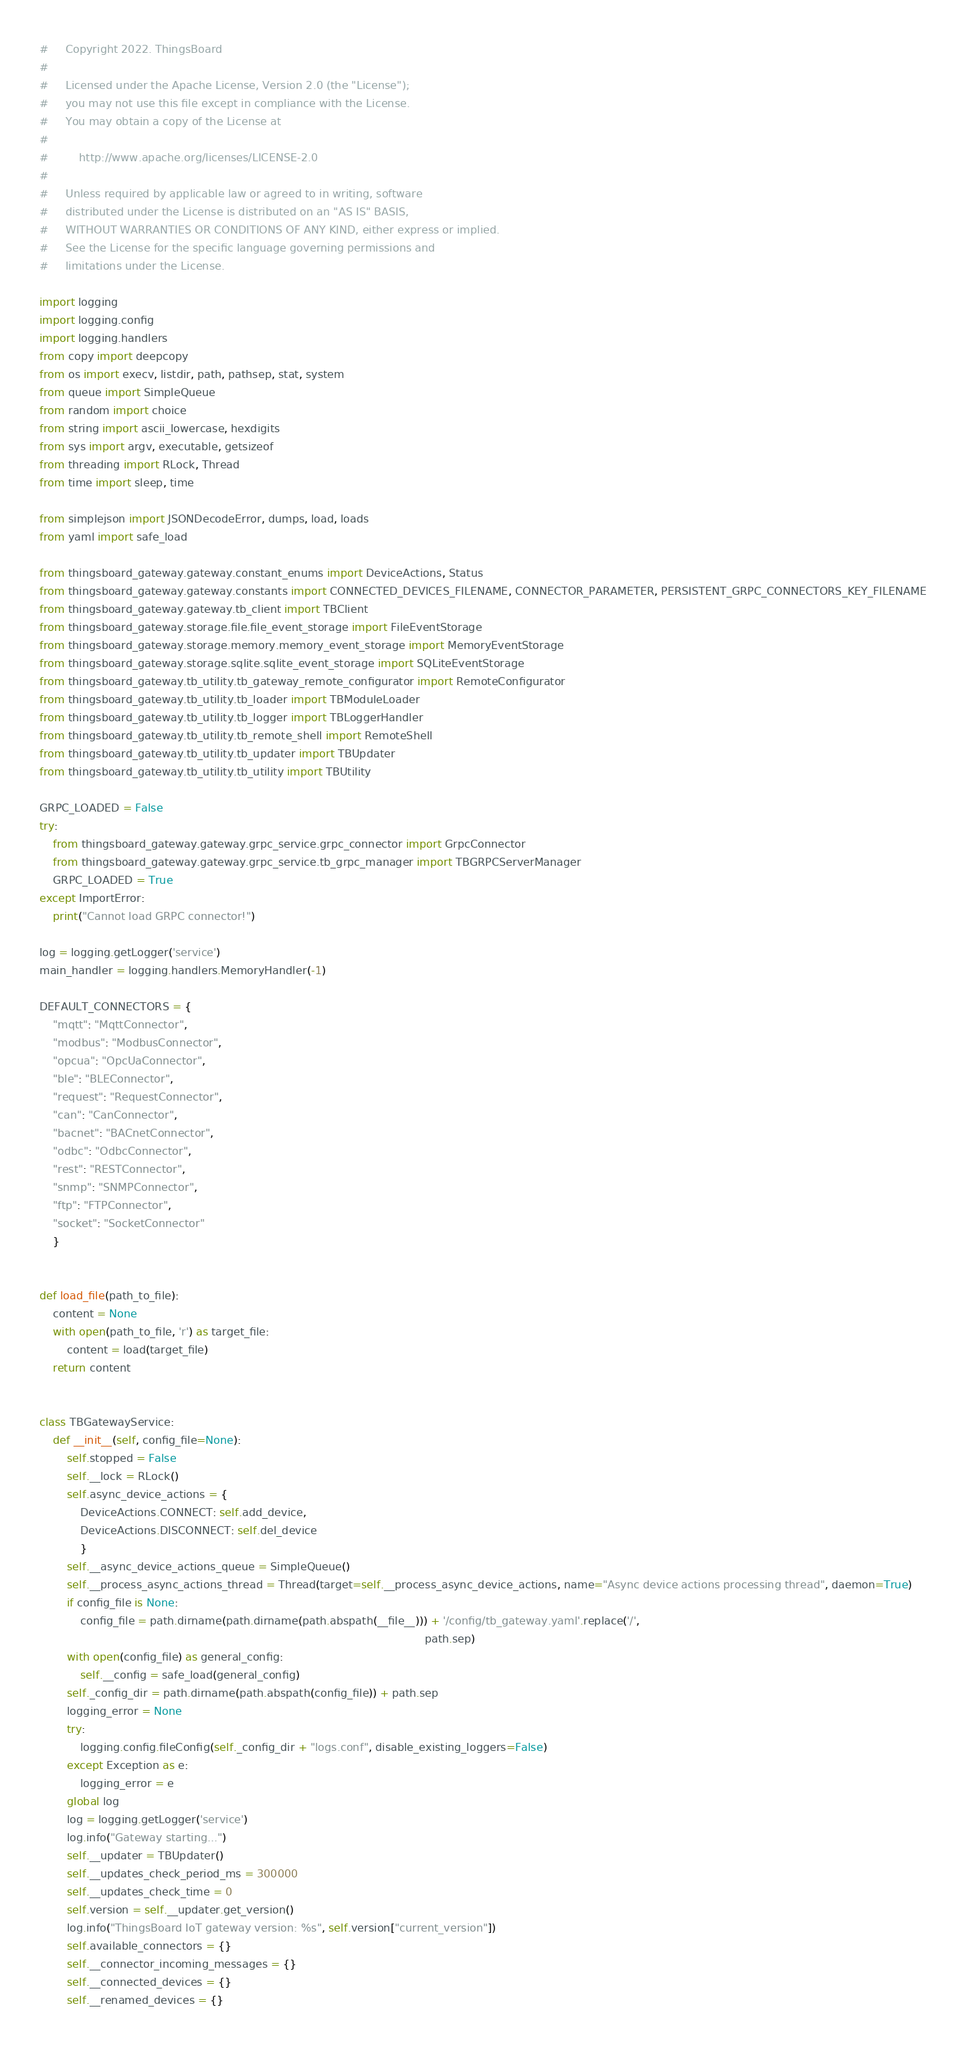<code> <loc_0><loc_0><loc_500><loc_500><_Python_>#     Copyright 2022. ThingsBoard
#
#     Licensed under the Apache License, Version 2.0 (the "License");
#     you may not use this file except in compliance with the License.
#     You may obtain a copy of the License at
#
#         http://www.apache.org/licenses/LICENSE-2.0
#
#     Unless required by applicable law or agreed to in writing, software
#     distributed under the License is distributed on an "AS IS" BASIS,
#     WITHOUT WARRANTIES OR CONDITIONS OF ANY KIND, either express or implied.
#     See the License for the specific language governing permissions and
#     limitations under the License.

import logging
import logging.config
import logging.handlers
from copy import deepcopy
from os import execv, listdir, path, pathsep, stat, system
from queue import SimpleQueue
from random import choice
from string import ascii_lowercase, hexdigits
from sys import argv, executable, getsizeof
from threading import RLock, Thread
from time import sleep, time

from simplejson import JSONDecodeError, dumps, load, loads
from yaml import safe_load

from thingsboard_gateway.gateway.constant_enums import DeviceActions, Status
from thingsboard_gateway.gateway.constants import CONNECTED_DEVICES_FILENAME, CONNECTOR_PARAMETER, PERSISTENT_GRPC_CONNECTORS_KEY_FILENAME
from thingsboard_gateway.gateway.tb_client import TBClient
from thingsboard_gateway.storage.file.file_event_storage import FileEventStorage
from thingsboard_gateway.storage.memory.memory_event_storage import MemoryEventStorage
from thingsboard_gateway.storage.sqlite.sqlite_event_storage import SQLiteEventStorage
from thingsboard_gateway.tb_utility.tb_gateway_remote_configurator import RemoteConfigurator
from thingsboard_gateway.tb_utility.tb_loader import TBModuleLoader
from thingsboard_gateway.tb_utility.tb_logger import TBLoggerHandler
from thingsboard_gateway.tb_utility.tb_remote_shell import RemoteShell
from thingsboard_gateway.tb_utility.tb_updater import TBUpdater
from thingsboard_gateway.tb_utility.tb_utility import TBUtility

GRPC_LOADED = False
try:
    from thingsboard_gateway.gateway.grpc_service.grpc_connector import GrpcConnector
    from thingsboard_gateway.gateway.grpc_service.tb_grpc_manager import TBGRPCServerManager
    GRPC_LOADED = True
except ImportError:
    print("Cannot load GRPC connector!")

log = logging.getLogger('service')
main_handler = logging.handlers.MemoryHandler(-1)

DEFAULT_CONNECTORS = {
    "mqtt": "MqttConnector",
    "modbus": "ModbusConnector",
    "opcua": "OpcUaConnector",
    "ble": "BLEConnector",
    "request": "RequestConnector",
    "can": "CanConnector",
    "bacnet": "BACnetConnector",
    "odbc": "OdbcConnector",
    "rest": "RESTConnector",
    "snmp": "SNMPConnector",
    "ftp": "FTPConnector",
    "socket": "SocketConnector"
    }


def load_file(path_to_file):
    content = None
    with open(path_to_file, 'r') as target_file:
        content = load(target_file)
    return content


class TBGatewayService:
    def __init__(self, config_file=None):
        self.stopped = False
        self.__lock = RLock()
        self.async_device_actions = {
            DeviceActions.CONNECT: self.add_device,
            DeviceActions.DISCONNECT: self.del_device
            }
        self.__async_device_actions_queue = SimpleQueue()
        self.__process_async_actions_thread = Thread(target=self.__process_async_device_actions, name="Async device actions processing thread", daemon=True)
        if config_file is None:
            config_file = path.dirname(path.dirname(path.abspath(__file__))) + '/config/tb_gateway.yaml'.replace('/',
                                                                                                                 path.sep)
        with open(config_file) as general_config:
            self.__config = safe_load(general_config)
        self._config_dir = path.dirname(path.abspath(config_file)) + path.sep
        logging_error = None
        try:
            logging.config.fileConfig(self._config_dir + "logs.conf", disable_existing_loggers=False)
        except Exception as e:
            logging_error = e
        global log
        log = logging.getLogger('service')
        log.info("Gateway starting...")
        self.__updater = TBUpdater()
        self.__updates_check_period_ms = 300000
        self.__updates_check_time = 0
        self.version = self.__updater.get_version()
        log.info("ThingsBoard IoT gateway version: %s", self.version["current_version"])
        self.available_connectors = {}
        self.__connector_incoming_messages = {}
        self.__connected_devices = {}
        self.__renamed_devices = {}</code> 